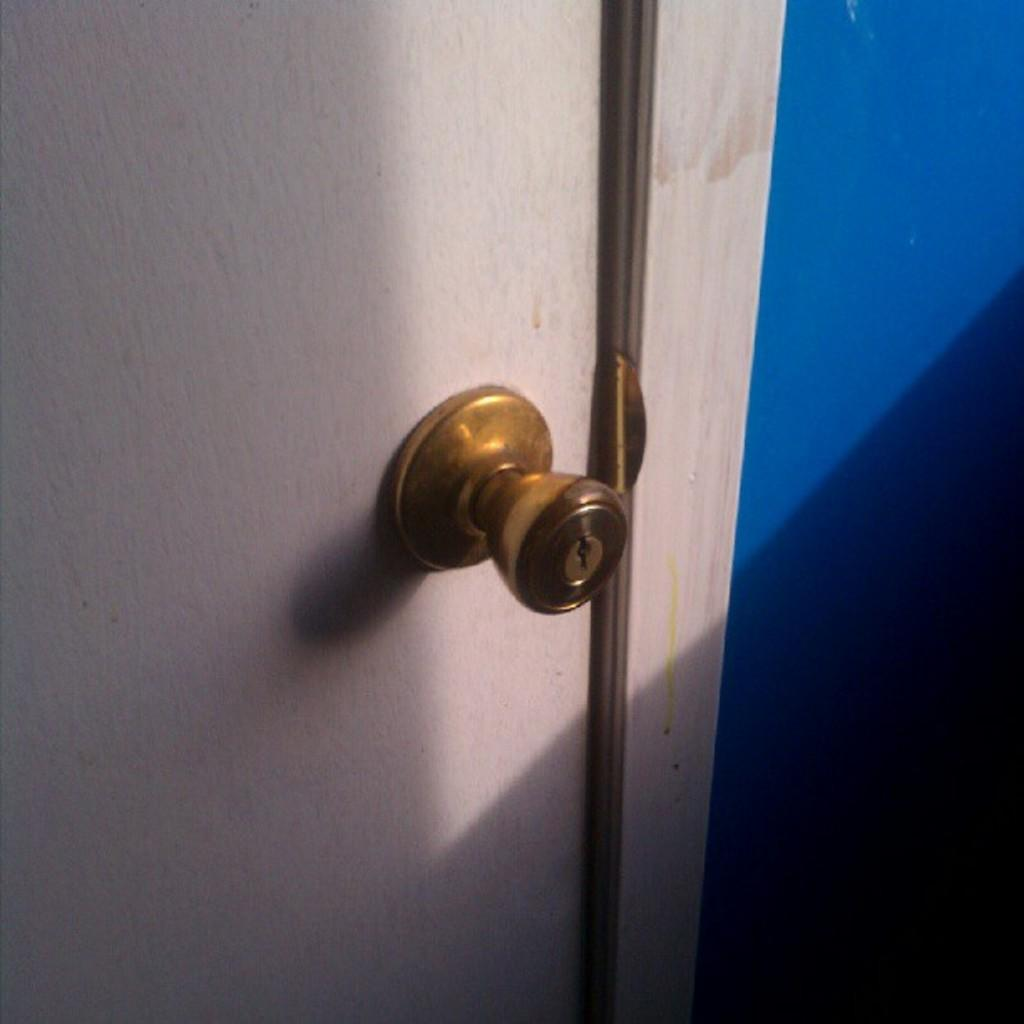What type of door is visible in the image? There is a white door in the image. What material is the knob on the door made of? The door has a metal knob on it. Is the woman wearing a hat while walking on the sidewalk in the image? There is no woman or sidewalk present in the image; it only features a white door with a metal knob. 